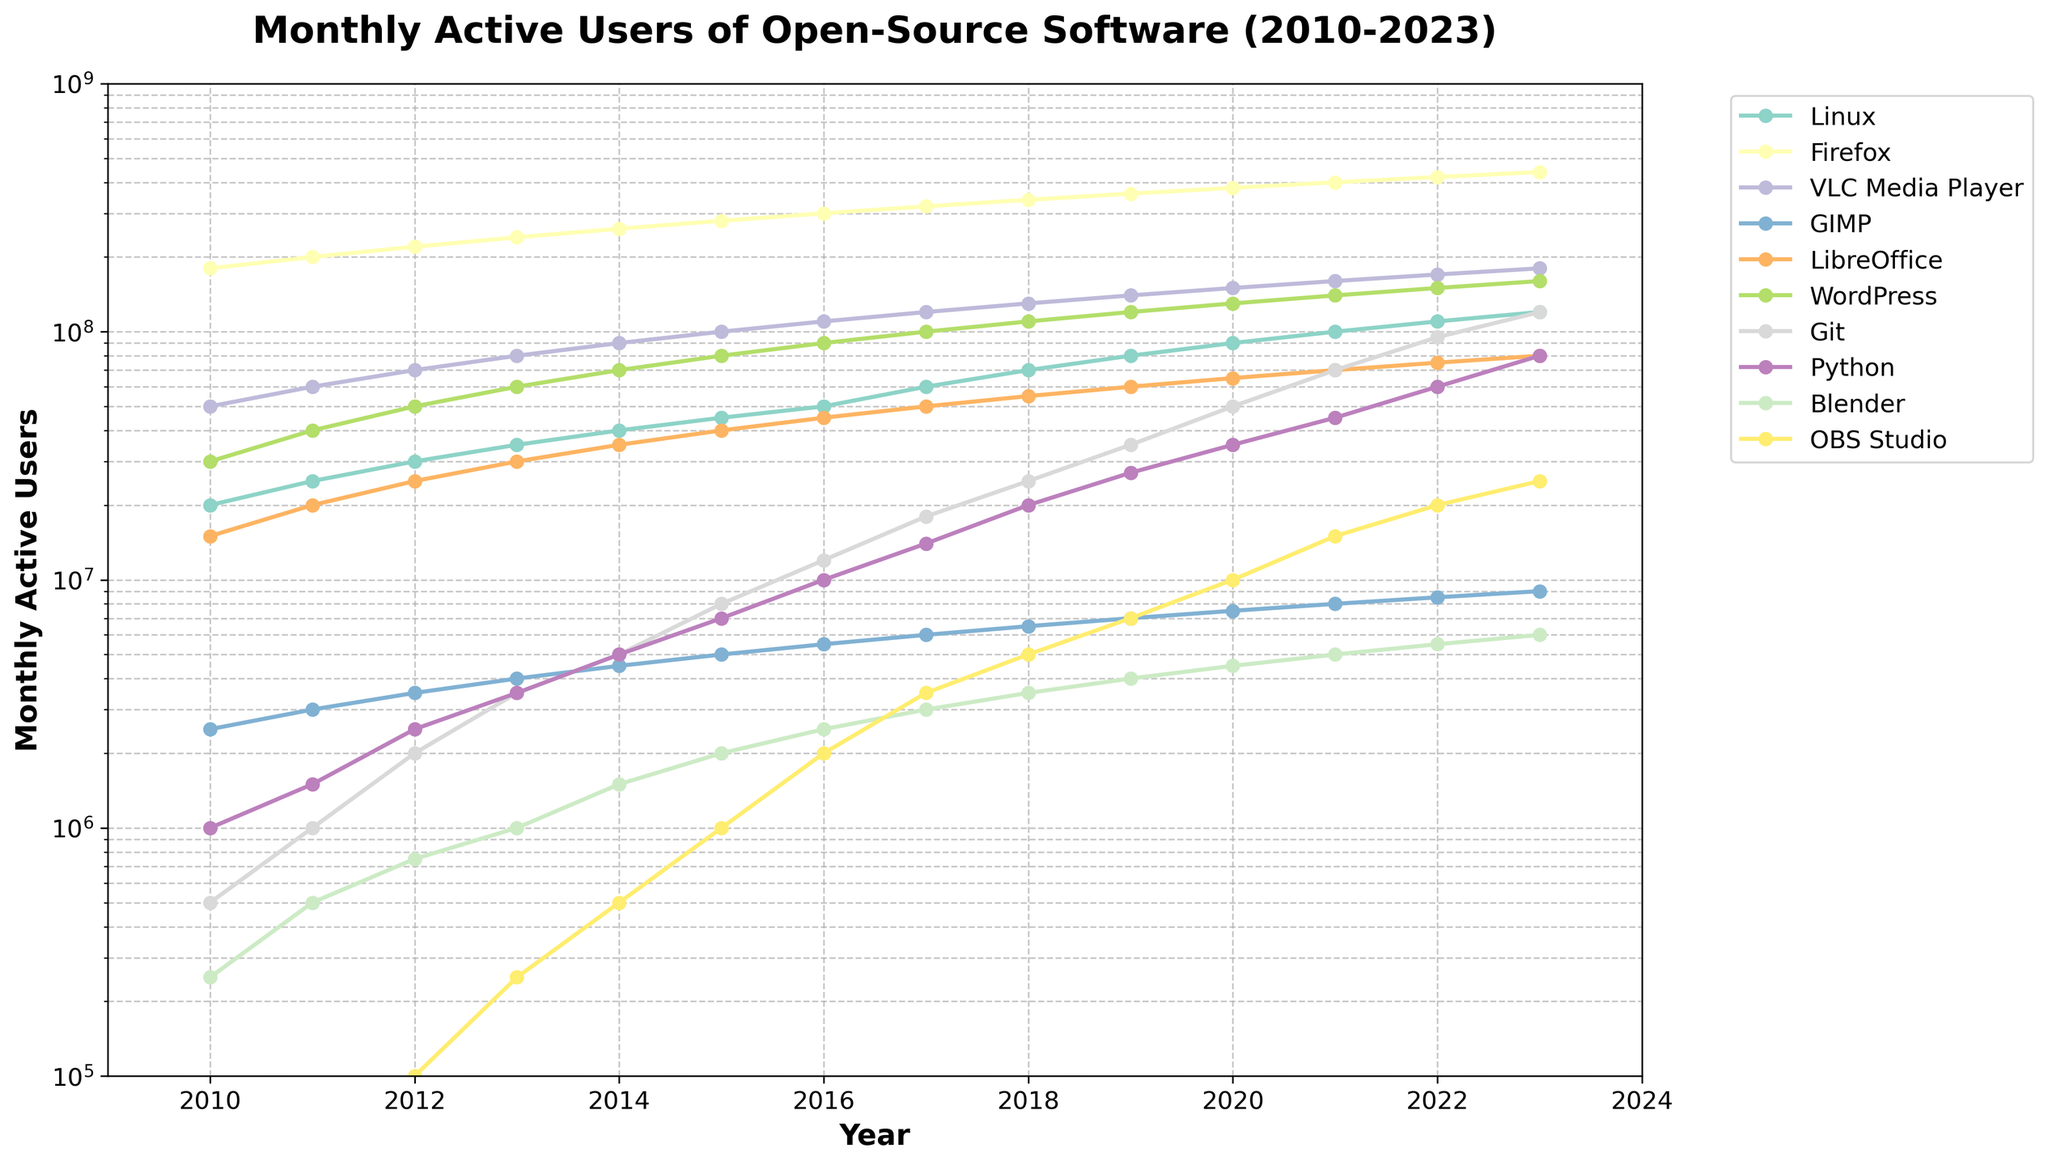What was the number of monthly active users for Python in 2015 and how much did it increase by 2022? First, find the value for Python in 2015, which is 7,000,000. Then find the value in 2022, which is 60,000,000. Calculate the increase: 60,000,000 - 7,000,000 = 53,000,000.
Answer: 53,000,000 Which software had the highest number of monthly active users in 2020? Look at the values for each software in 2020 and identify the highest one. Firefox had 380,000,000 users, the highest for that year.
Answer: Firefox What is the difference between the monthly active users of Linux and Git in 2017? Find the value for Linux in 2017, which is 60,000,000, and for Git, which is 18,000,000. The difference is 60,000,000 - 18,000,000 = 42,000,000.
Answer: 42,000,000 How did the monthly active users of OBS Studio change from 2010 to 2023? In 2010, OBS Studio had 0 users, and in 2023 it had 25,000,000. The change is 25,000,000 - 0 = 25,000,000.
Answer: 25,000,000 Which year did LibreOffice first surpass 50,000,000 monthly active users? Find the year where LibreOffice first exceeds 50,000,000. In 2017, it surpassed 50,000,000 with exactly 50,000,000 monthly active users.
Answer: 2017 Compare the monthly active users of VLC Media Player and Blender in 2019. Which one had more users and by how much? VLC Media Player had 140,000,000 users, while Blender had 4,000,000 users. The difference is 140,000,000 - 4,000,000 = 136,000,000. Thus, VLC had more users.
Answer: VLC Media Player by 136,000,000 What was the percentage increase in the monthly active users of WordPress from 2010 to 2023? WordPress users in 2010 were 30,000,000 and in 2023 were 160,000,000. The increase is 160,000,000 - 30,000,000 = 130,000,000. The percentage increase is (130,000,000 / 30,000,000) * 100 ≈ 433.33%.
Answer: 433.33% Identify the software with the steepest increase in monthly users between any two consecutive years. Look at the differences year by year for each software. The steepest increase is from Git between 2020 (50,000,000) and 2021 (70,000,000), which is an increase of 20,000,000.
Answer: Git Which three software had the lowest number of monthly active users in 2014? In 2014, the lowest three numbers were: GIMP (4,500,000), Blender (1,500,000), and OBS Studio (500,000).
Answer: GIMP, Blender, OBS Studio 